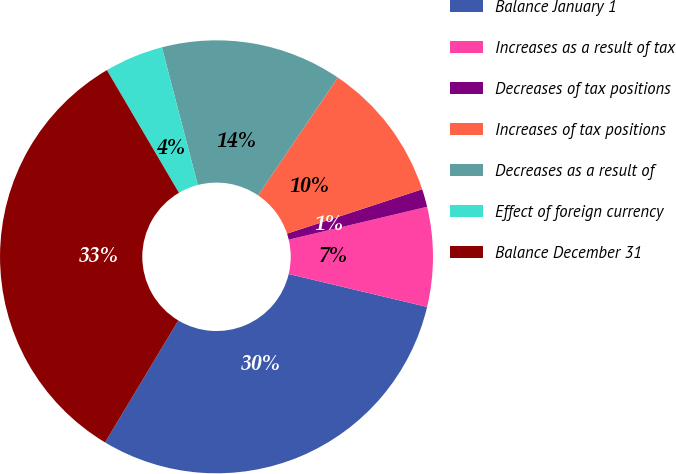<chart> <loc_0><loc_0><loc_500><loc_500><pie_chart><fcel>Balance January 1<fcel>Increases as a result of tax<fcel>Decreases of tax positions<fcel>Increases of tax positions<fcel>Decreases as a result of<fcel>Effect of foreign currency<fcel>Balance December 31<nl><fcel>29.89%<fcel>7.43%<fcel>1.34%<fcel>10.48%<fcel>13.53%<fcel>4.39%<fcel>32.94%<nl></chart> 